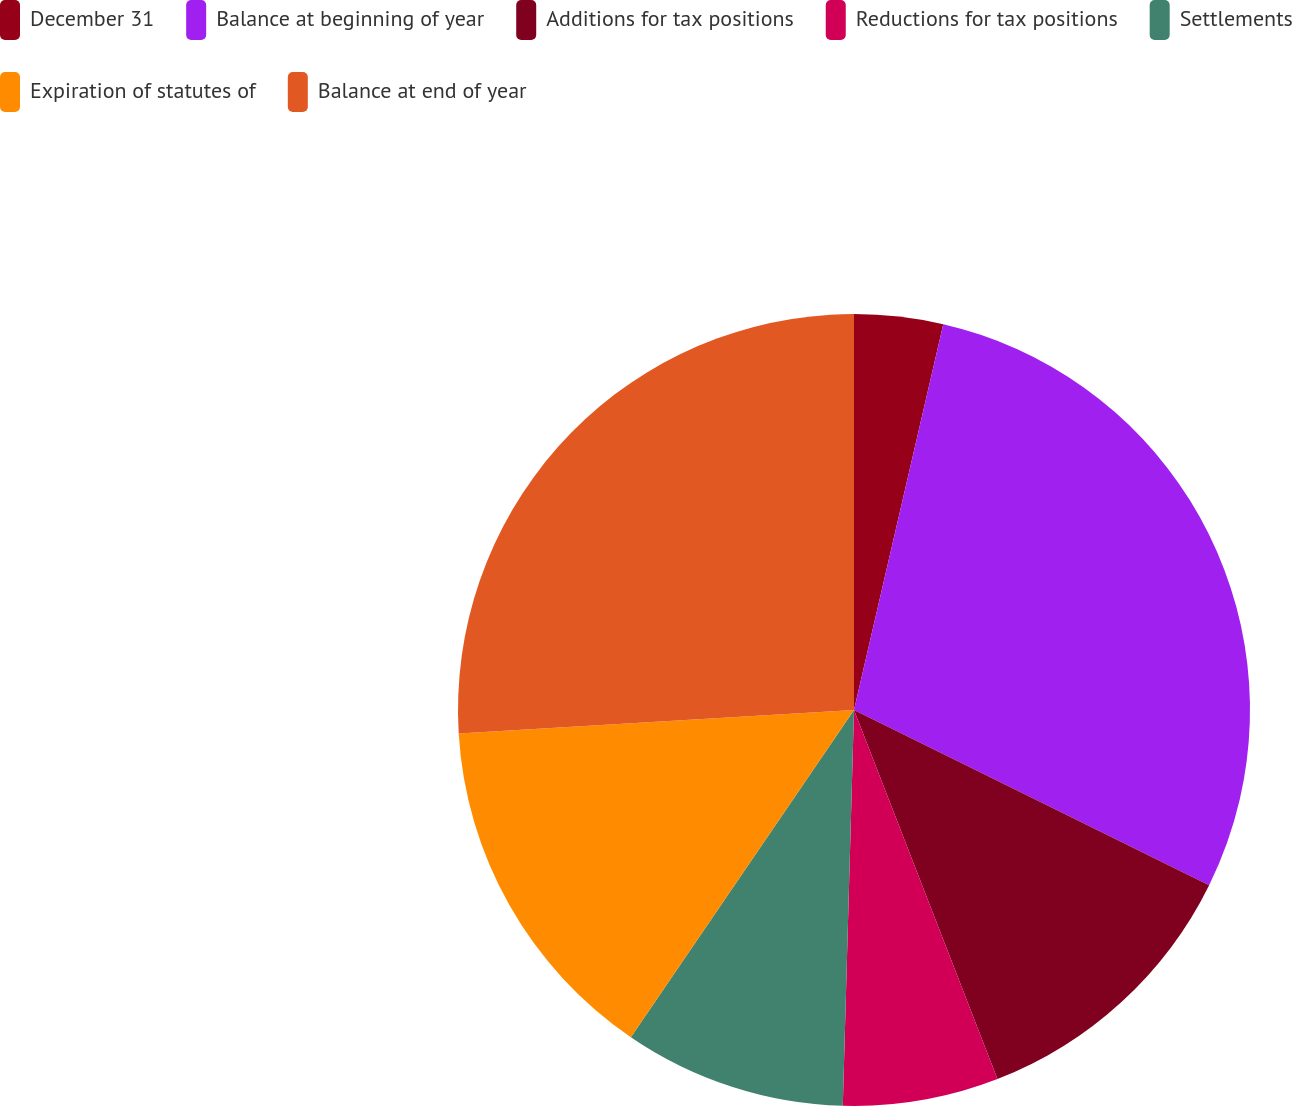Convert chart to OTSL. <chart><loc_0><loc_0><loc_500><loc_500><pie_chart><fcel>December 31<fcel>Balance at beginning of year<fcel>Additions for tax positions<fcel>Reductions for tax positions<fcel>Settlements<fcel>Expiration of statutes of<fcel>Balance at end of year<nl><fcel>3.62%<fcel>28.68%<fcel>11.81%<fcel>6.35%<fcel>9.08%<fcel>14.53%<fcel>25.95%<nl></chart> 